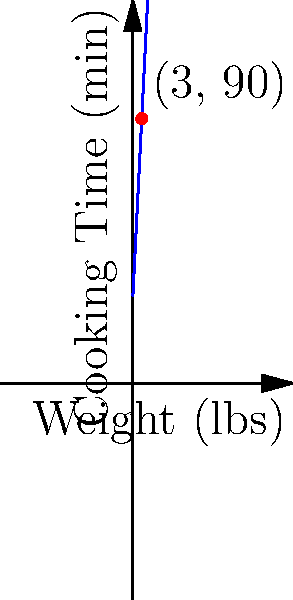Mrs. Johnson, your kind neighbor, has offered to cook a roast for your Sunday dinner. She knows you enjoy well-cooked meat and follows a simple rule for roasting: 20 minutes per pound, plus an additional 30 minutes. If Mrs. Johnson is preparing a 3-pound roast, how long should she cook it to ensure it's perfectly done for you? Let's approach this step-by-step:

1) First, we need to understand the cooking rule:
   - 20 minutes per pound
   - Plus an additional 30 minutes

2) We can express this as a mathematical function:
   $T = 20w + 30$
   Where $T$ is the total cooking time in minutes, and $w$ is the weight in pounds.

3) We're told the roast weighs 3 pounds, so we substitute $w = 3$ into our equation:
   $T = 20(3) + 30$

4) Now let's solve:
   $T = 60 + 30$
   $T = 90$

5) Therefore, the total cooking time is 90 minutes.

The graph shows this relationship, with the red dot indicating the point (3, 90) for our 3-pound roast.
Answer: 90 minutes 